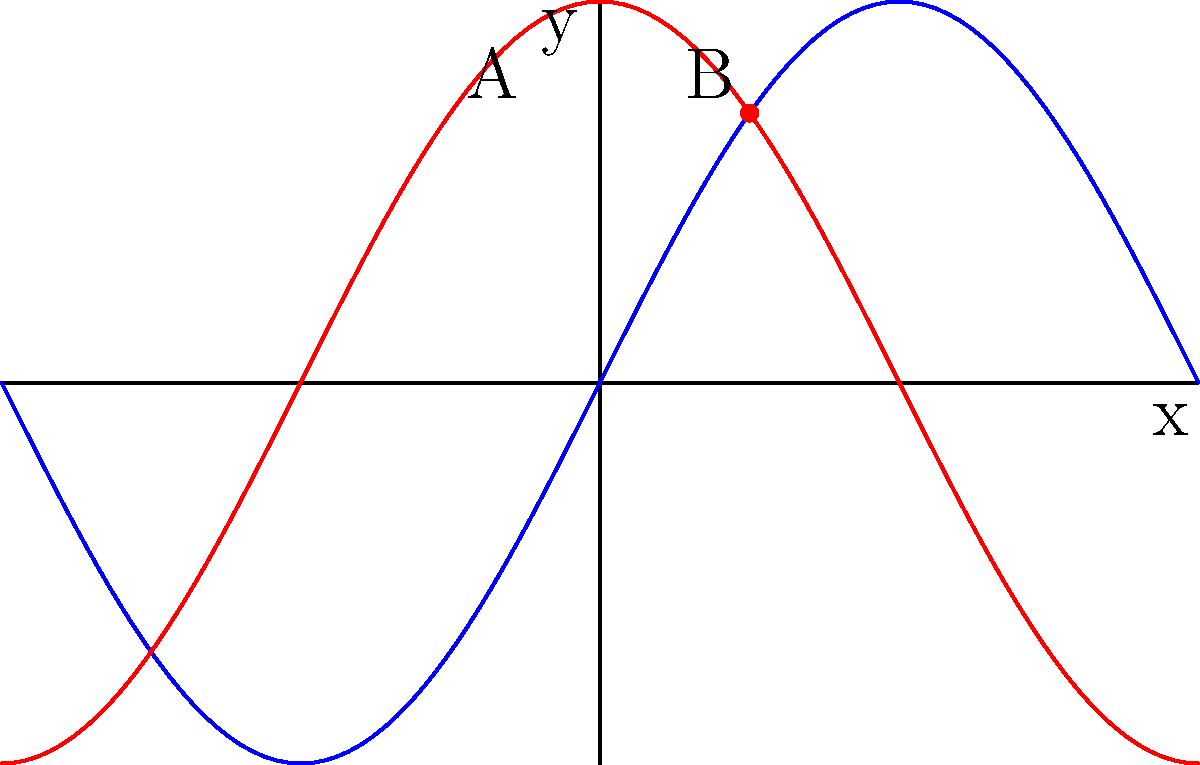Professor Brindley once taught us about sinusoidal functions and their derivatives. Consider the function $f(x)=2\sin(x)$ shown in blue, with its derivative $f'(x)$ shown in red. At the point $x=\frac{\pi}{4}$, what is the rate of change of $f(x)$? Let's approach this step-by-step:

1) The rate of change of a function at any point is given by its derivative at that point.

2) For $f(x)=2\sin(x)$, we can find $f'(x)$ using the chain rule:
   $f'(x) = 2 \cdot \frac{d}{dx}[\sin(x)] = 2\cos(x)$

3) Now, we need to evaluate $f'(x)$ at $x=\frac{\pi}{4}$:
   $f'(\frac{\pi}{4}) = 2\cos(\frac{\pi}{4})$

4) Recall that $\cos(\frac{\pi}{4}) = \frac{\sqrt{2}}{2}$

5) Therefore:
   $f'(\frac{\pi}{4}) = 2 \cdot \frac{\sqrt{2}}{2} = \sqrt{2}$

6) On the graph, this value corresponds to the y-coordinate of point B on the red curve.
Answer: $\sqrt{2}$ 